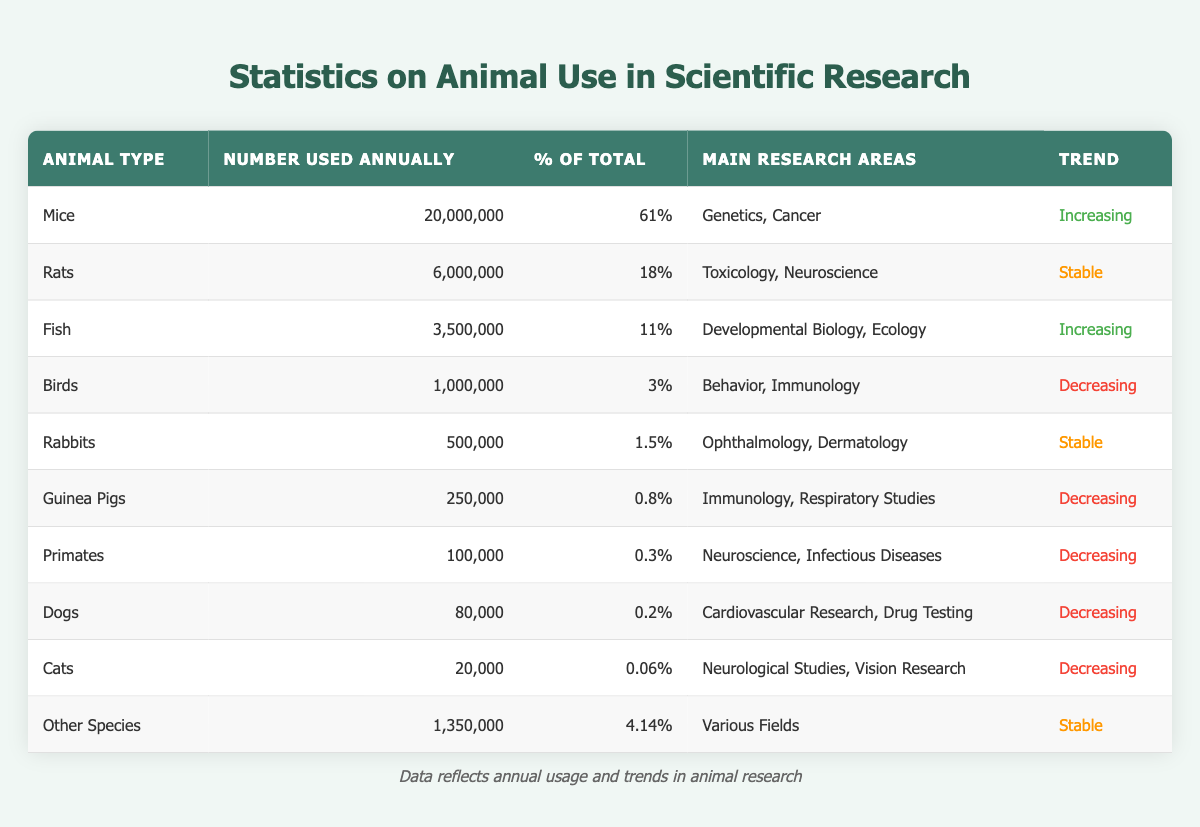What is the most commonly used animal in scientific research? The most commonly used animal can be identified by looking for the highest number in the "Number Used Annually" column. Mice are listed with 20,000,000, which is the highest number among all the species in the table.
Answer: Mice What percentage of the total animals used in research are represented by fish? To find the percentage of fish used in research, we refer to the "% of Total" column, where fish are indicated to account for 11% of the total animals.
Answer: 11% How many more mice are used annually compared to cats? We can find the difference by subtracting the number of cats (20,000) from the number of mice (20,000,000). This calculation gives us 20,000,000 - 20,000 = 19,980,000.
Answer: 19,980,000 Are more animals used in the increasing trend than in the decreasing trend? We analyze the "Trend" column to categorize the animals: Mice (increasing), Fish (increasing), with a total of 23,500,000 animals. In contrast, the decreasing trend includes Birds, Guinea Pigs, Primates, Dogs, and Cats, totaling 1,100,000 animals. Since 23,500,000 is greater than 1,100,000, the answer is yes.
Answer: Yes What is the total number of animals used in stable research trends? The stable research trends include Rats (6,000,000), Rabbits (500,000), and Other Species (1,350,000). By summing these, we find 6,000,000 + 500,000 + 1,350,000 = 7,850,000.
Answer: 7,850,000 Which type of animal has the lowest usage in scientific research? To ascertain the animal with the lowest usage, we check the "Number Used Annually" column. The data shows that Cats have the lowest figure at 20,000.
Answer: Cats What percentage of total usage is made up by primates? Referring to the "% of Total" column, primates account for 0.3% of the total animals used in research.
Answer: 0.3% Is the trend for birds in scientific research increasing? By examining the "Trend" column specifically for birds, it indicates that their usage is in a decreasing trend. Therefore, the answer is no.
Answer: No 